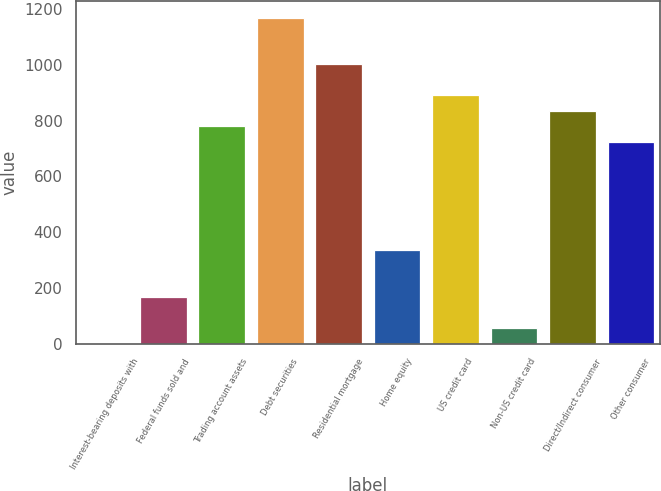Convert chart to OTSL. <chart><loc_0><loc_0><loc_500><loc_500><bar_chart><fcel>Interest-bearing deposits with<fcel>Federal funds sold and<fcel>Trading account assets<fcel>Debt securities<fcel>Residential mortgage<fcel>Home equity<fcel>US credit card<fcel>Non-US credit card<fcel>Direct/Indirect consumer<fcel>Other consumer<nl><fcel>1<fcel>167.8<fcel>779.4<fcel>1168.6<fcel>1001.8<fcel>334.6<fcel>890.6<fcel>56.6<fcel>835<fcel>723.8<nl></chart> 